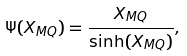<formula> <loc_0><loc_0><loc_500><loc_500>\Psi ( X _ { M Q } ) = \frac { X _ { M Q } } { \sinh ( X _ { M Q } ) } ,</formula> 